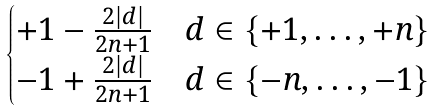<formula> <loc_0><loc_0><loc_500><loc_500>\begin{cases} + 1 - \frac { 2 | d | } { 2 n + 1 } & d \in \{ + 1 , \dots , + n \} \\ - 1 + \frac { 2 | d | } { 2 n + 1 } & d \in \{ - n , \dots , - 1 \} \end{cases}</formula> 